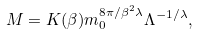<formula> <loc_0><loc_0><loc_500><loc_500>M = K ( \beta ) m _ { 0 } ^ { 8 \pi / \beta ^ { 2 } \lambda } \Lambda ^ { - 1 / \lambda } ,</formula> 